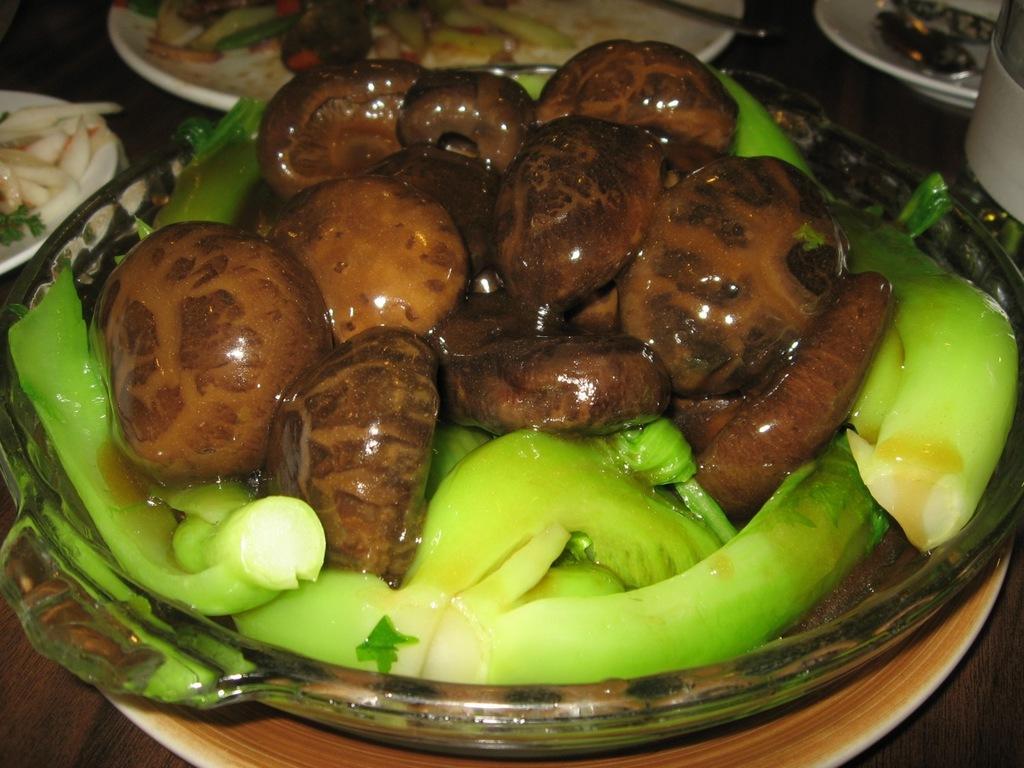Could you give a brief overview of what you see in this image? In this image we can see a food item which is in brown and green color which is in a plate and in the background of the image there are some food items which are in plates which are on table. 